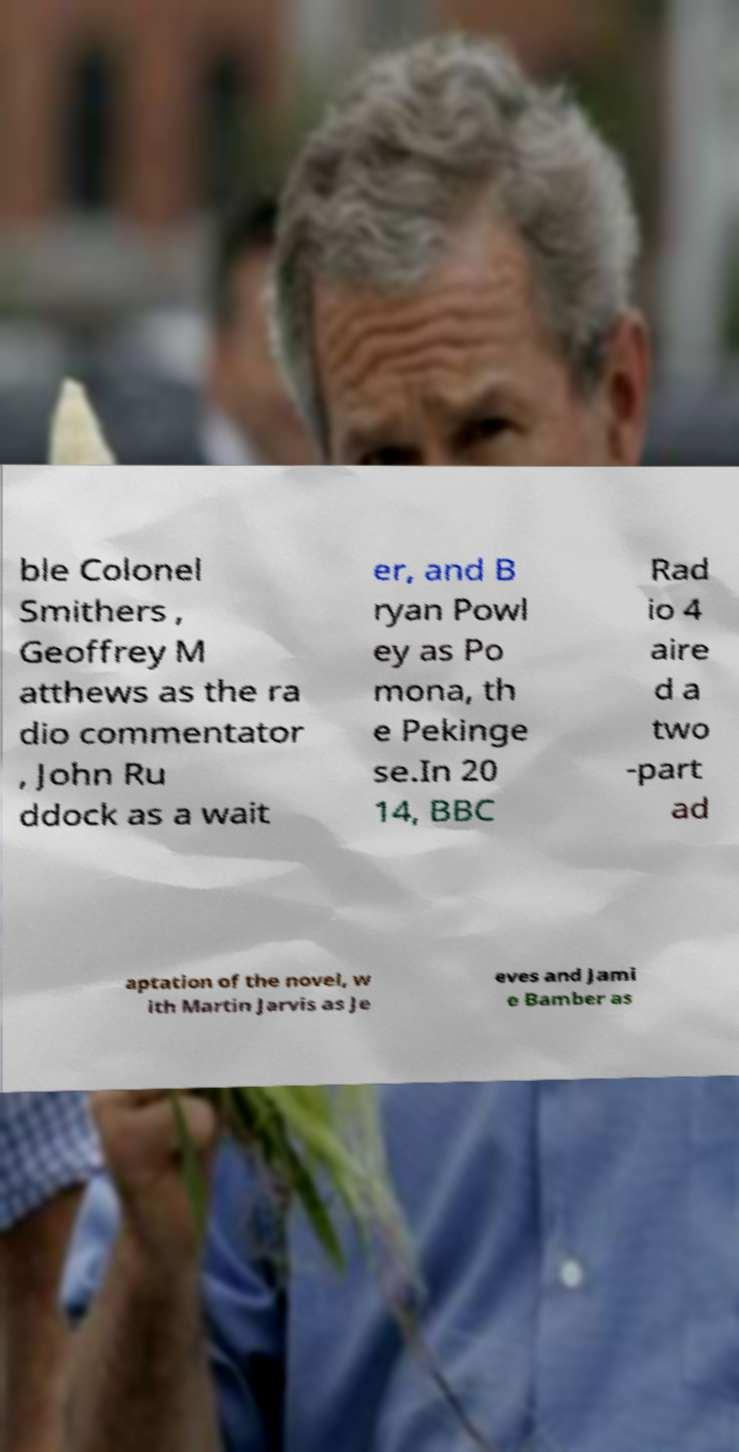Could you extract and type out the text from this image? ble Colonel Smithers , Geoffrey M atthews as the ra dio commentator , John Ru ddock as a wait er, and B ryan Powl ey as Po mona, th e Pekinge se.In 20 14, BBC Rad io 4 aire d a two -part ad aptation of the novel, w ith Martin Jarvis as Je eves and Jami e Bamber as 